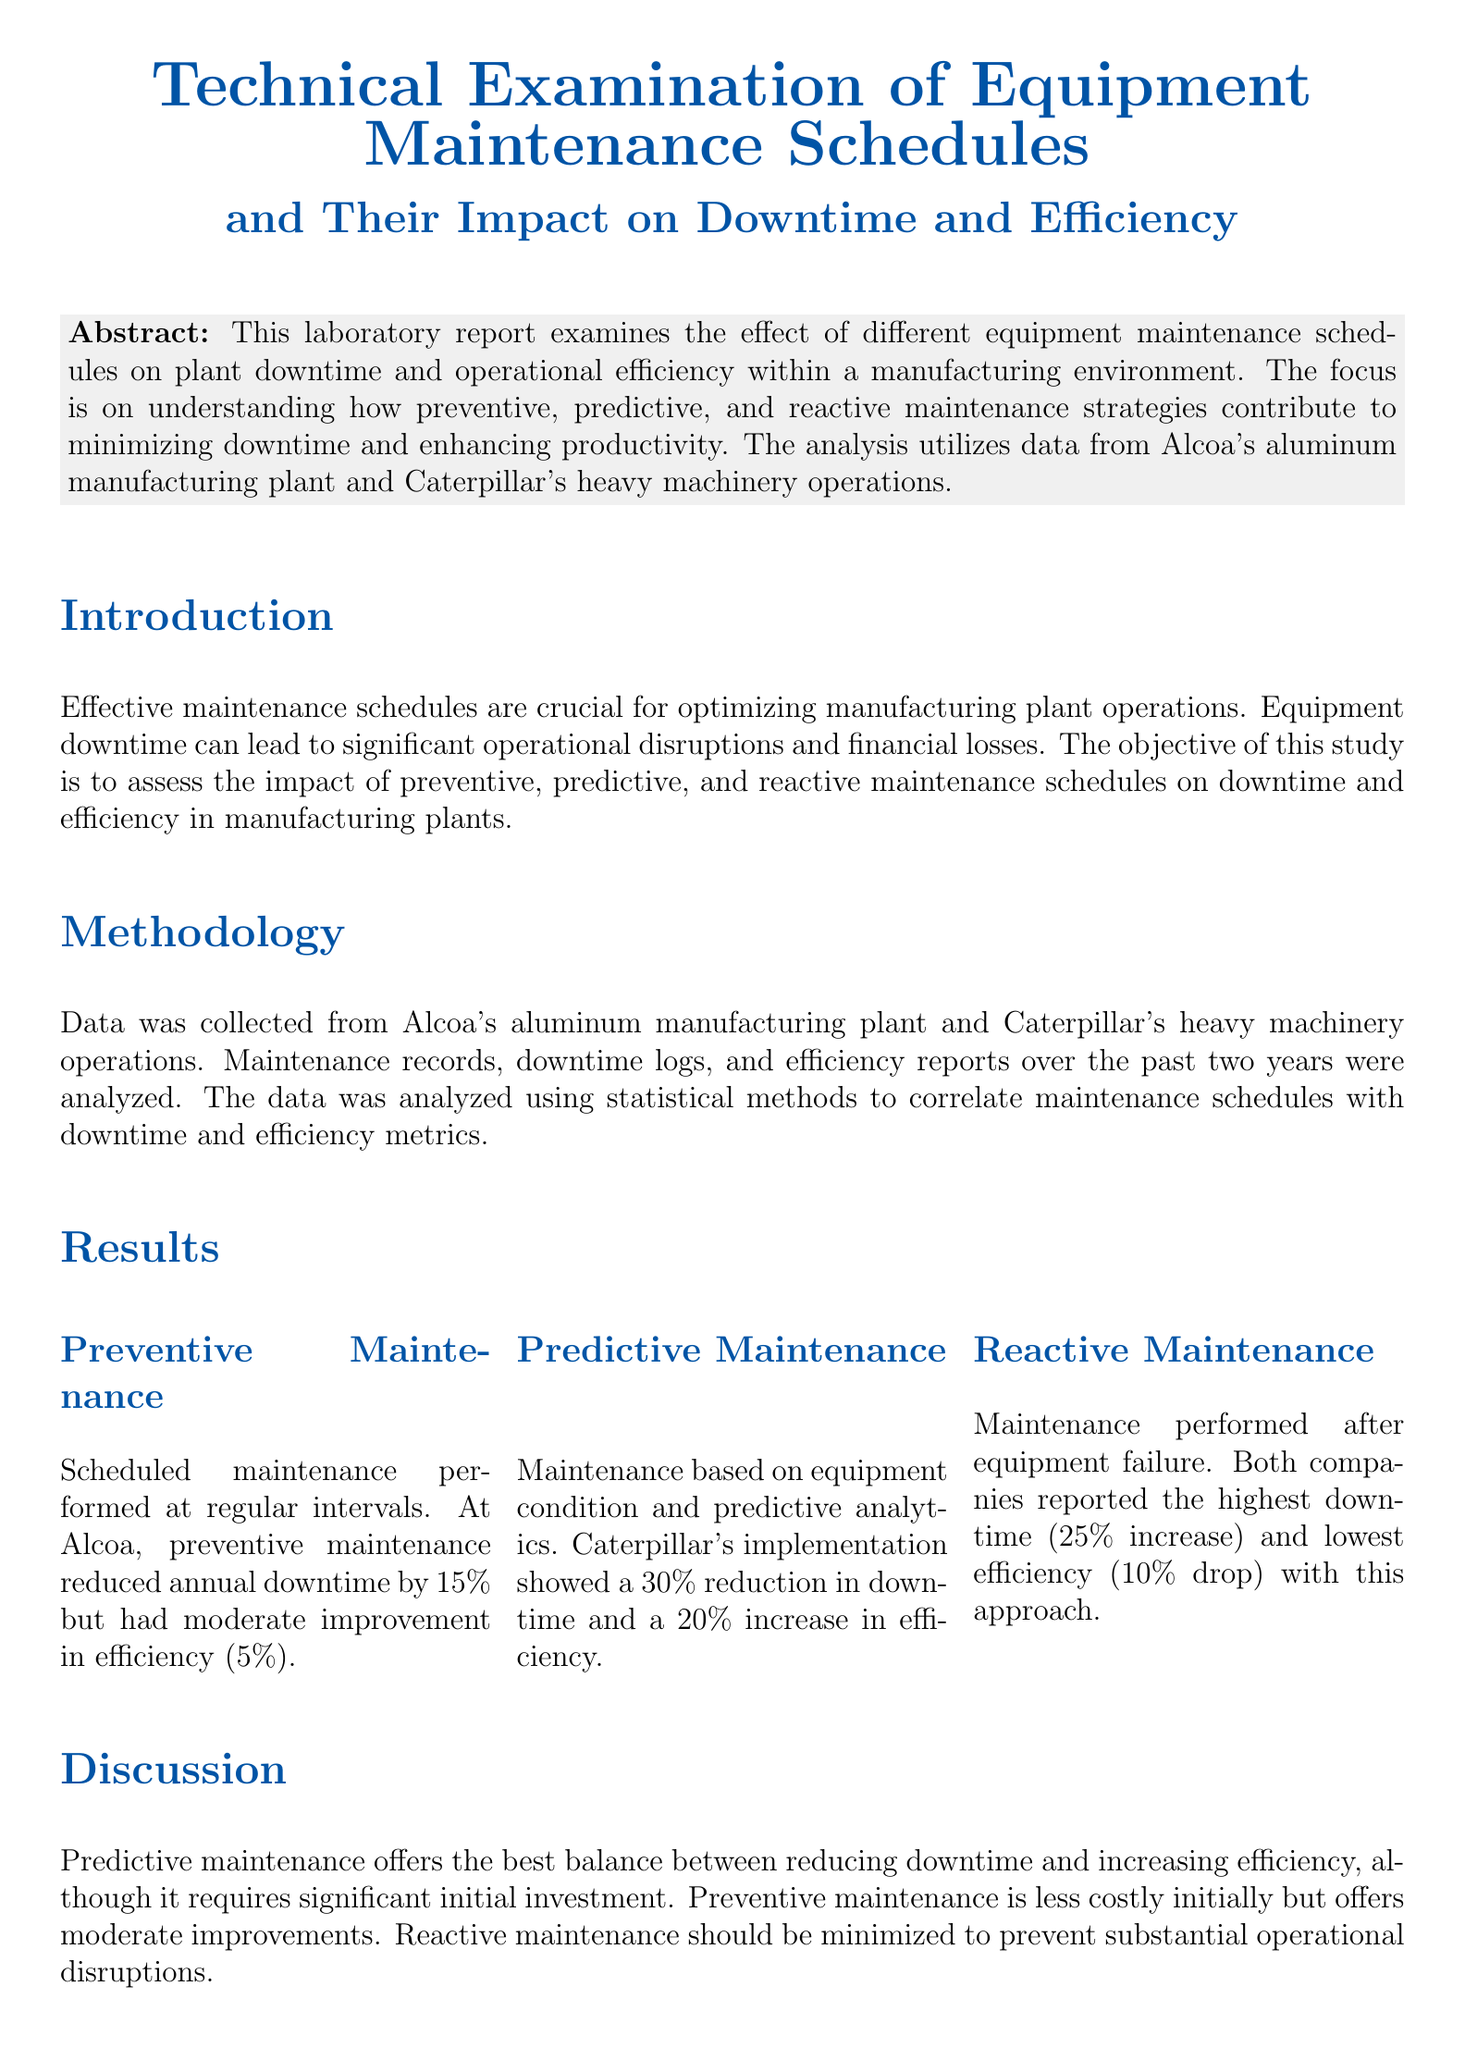What is the main focus of the lab report? The main focus of the report is to examine the effect of different equipment maintenance schedules on plant downtime and operational efficiency.
Answer: Equipment maintenance schedules What was the percentage reduction in annual downtime due to preventive maintenance at Alcoa? Preventive maintenance reduced annual downtime by 15 percent at Alcoa.
Answer: 15% Which maintenance strategy showed the highest increase in efficiency at Caterpillar? Predictive maintenance at Caterpillar showed a 20 percent increase in efficiency.
Answer: Predictive maintenance What type of maintenance led to a 25 percent increase in downtime? Reactive maintenance led to a 25 percent increase in downtime for both companies.
Answer: Reactive maintenance What are two recommendations for plant managers mentioned in the report? The report recommends investing in predictive maintenance technologies and training staff to interpret predictive data, among others.
Answer: Invest in predictive maintenance technologies, train staff What is the overall conclusion regarding maintenance strategies in manufacturing plants? The examination concludes that predictive maintenance is the most effective strategy for minimizing downtime and enhancing efficiency.
Answer: Predictive maintenance What is the initial investment requirement for predictive maintenance described in the discussion? Predictive maintenance requires significant initial investment.
Answer: Significant initial investment What impact did predictive maintenance have on downtime percentages? Predictive maintenance implementation showed a 30 percent reduction in downtime.
Answer: 30% reduction 